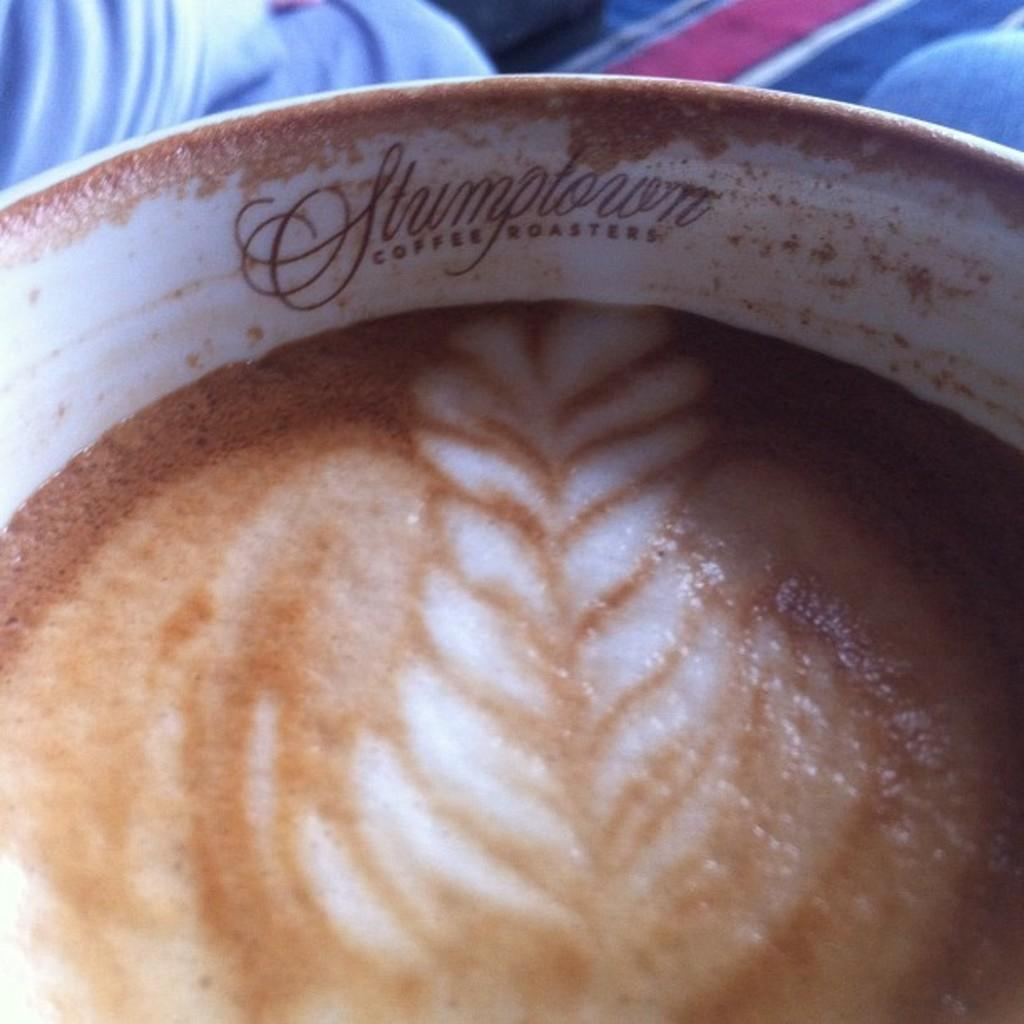What beverage is present in the image? There is coffee in the image. How many deer can be seen in the image? There are no deer present in the image; it only features coffee. What type of home is shown in the image? The image does not depict a home; it only features coffee. 